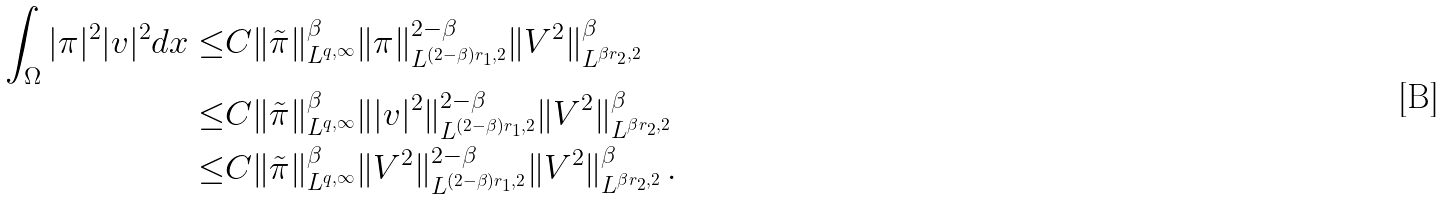Convert formula to latex. <formula><loc_0><loc_0><loc_500><loc_500>\int _ { \Omega } | \pi | ^ { 2 } | v | ^ { 2 } d x \leq & C \| \tilde { \pi } \| ^ { \beta } _ { L ^ { q , \infty } } \| \pi \| ^ { 2 - \beta } _ { L ^ { ( 2 - \beta ) r _ { 1 } , 2 } } \| V ^ { 2 } \| ^ { \beta } _ { L ^ { \beta r _ { 2 } , 2 } } \\ \leq & C \| \tilde { \pi } \| ^ { \beta } _ { L ^ { q , \infty } } \| | v | ^ { 2 } \| ^ { 2 - \beta } _ { L ^ { ( 2 - \beta ) r _ { 1 } , 2 } } \| V ^ { 2 } \| ^ { \beta } _ { L ^ { \beta r _ { 2 } , 2 } } \\ \leq & C \| \tilde { \pi } \| ^ { \beta } _ { L ^ { q , \infty } } \| V ^ { 2 } \| ^ { 2 - \beta } _ { L ^ { ( 2 - \beta ) r _ { 1 } , 2 } } \| V ^ { 2 } \| ^ { \beta } _ { L ^ { \beta r _ { 2 } , 2 } } \, .</formula> 